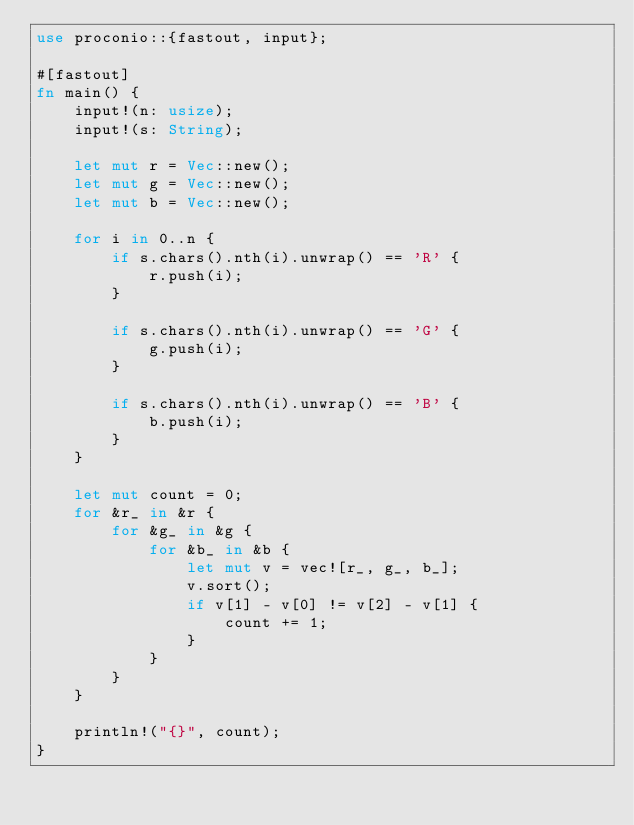<code> <loc_0><loc_0><loc_500><loc_500><_Rust_>use proconio::{fastout, input};

#[fastout]
fn main() {
    input!(n: usize);
    input!(s: String);

    let mut r = Vec::new();
    let mut g = Vec::new();
    let mut b = Vec::new();

    for i in 0..n {
        if s.chars().nth(i).unwrap() == 'R' {
            r.push(i);
        }

        if s.chars().nth(i).unwrap() == 'G' {
            g.push(i);
        }

        if s.chars().nth(i).unwrap() == 'B' {
            b.push(i);
        }
    }

    let mut count = 0;
    for &r_ in &r {
        for &g_ in &g {
            for &b_ in &b {
                let mut v = vec![r_, g_, b_];
                v.sort();
                if v[1] - v[0] != v[2] - v[1] {
                    count += 1;
                }
            }
        }
    }

    println!("{}", count);
}
</code> 